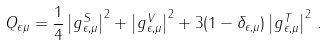Convert formula to latex. <formula><loc_0><loc_0><loc_500><loc_500>Q _ { \epsilon \mu } = \frac { 1 } { 4 } \left | g _ { \epsilon , \mu } ^ { S } \right | ^ { 2 } + \left | g _ { \epsilon , \mu } ^ { V } \right | ^ { 2 } + 3 ( 1 - \delta _ { \epsilon , \mu } ) \left | g _ { \epsilon , \mu } ^ { T } \right | ^ { 2 } \, .</formula> 